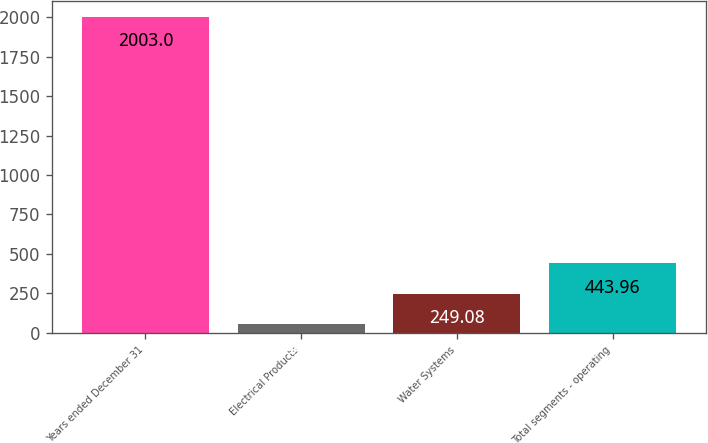<chart> <loc_0><loc_0><loc_500><loc_500><bar_chart><fcel>Years ended December 31<fcel>Electrical Products<fcel>Water Systems<fcel>Total segments - operating<nl><fcel>2003<fcel>54.2<fcel>249.08<fcel>443.96<nl></chart> 